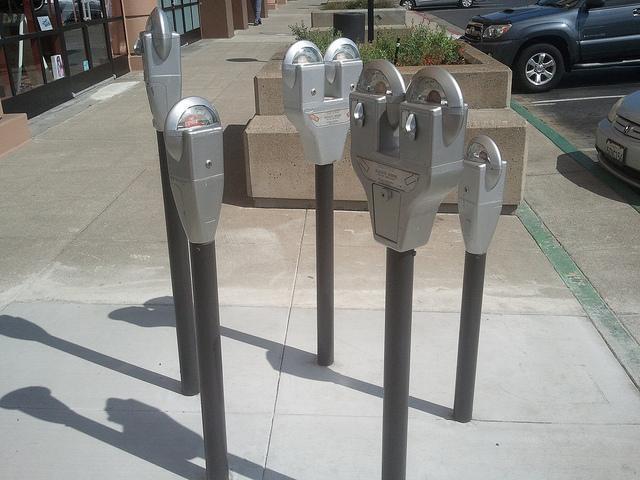How many cars do these meters currently monitor?
Choose the right answer and clarify with the format: 'Answer: answer
Rationale: rationale.'
Options: One, none, two, nine. Answer: none.
Rationale: It is unknown which meters are being used. 